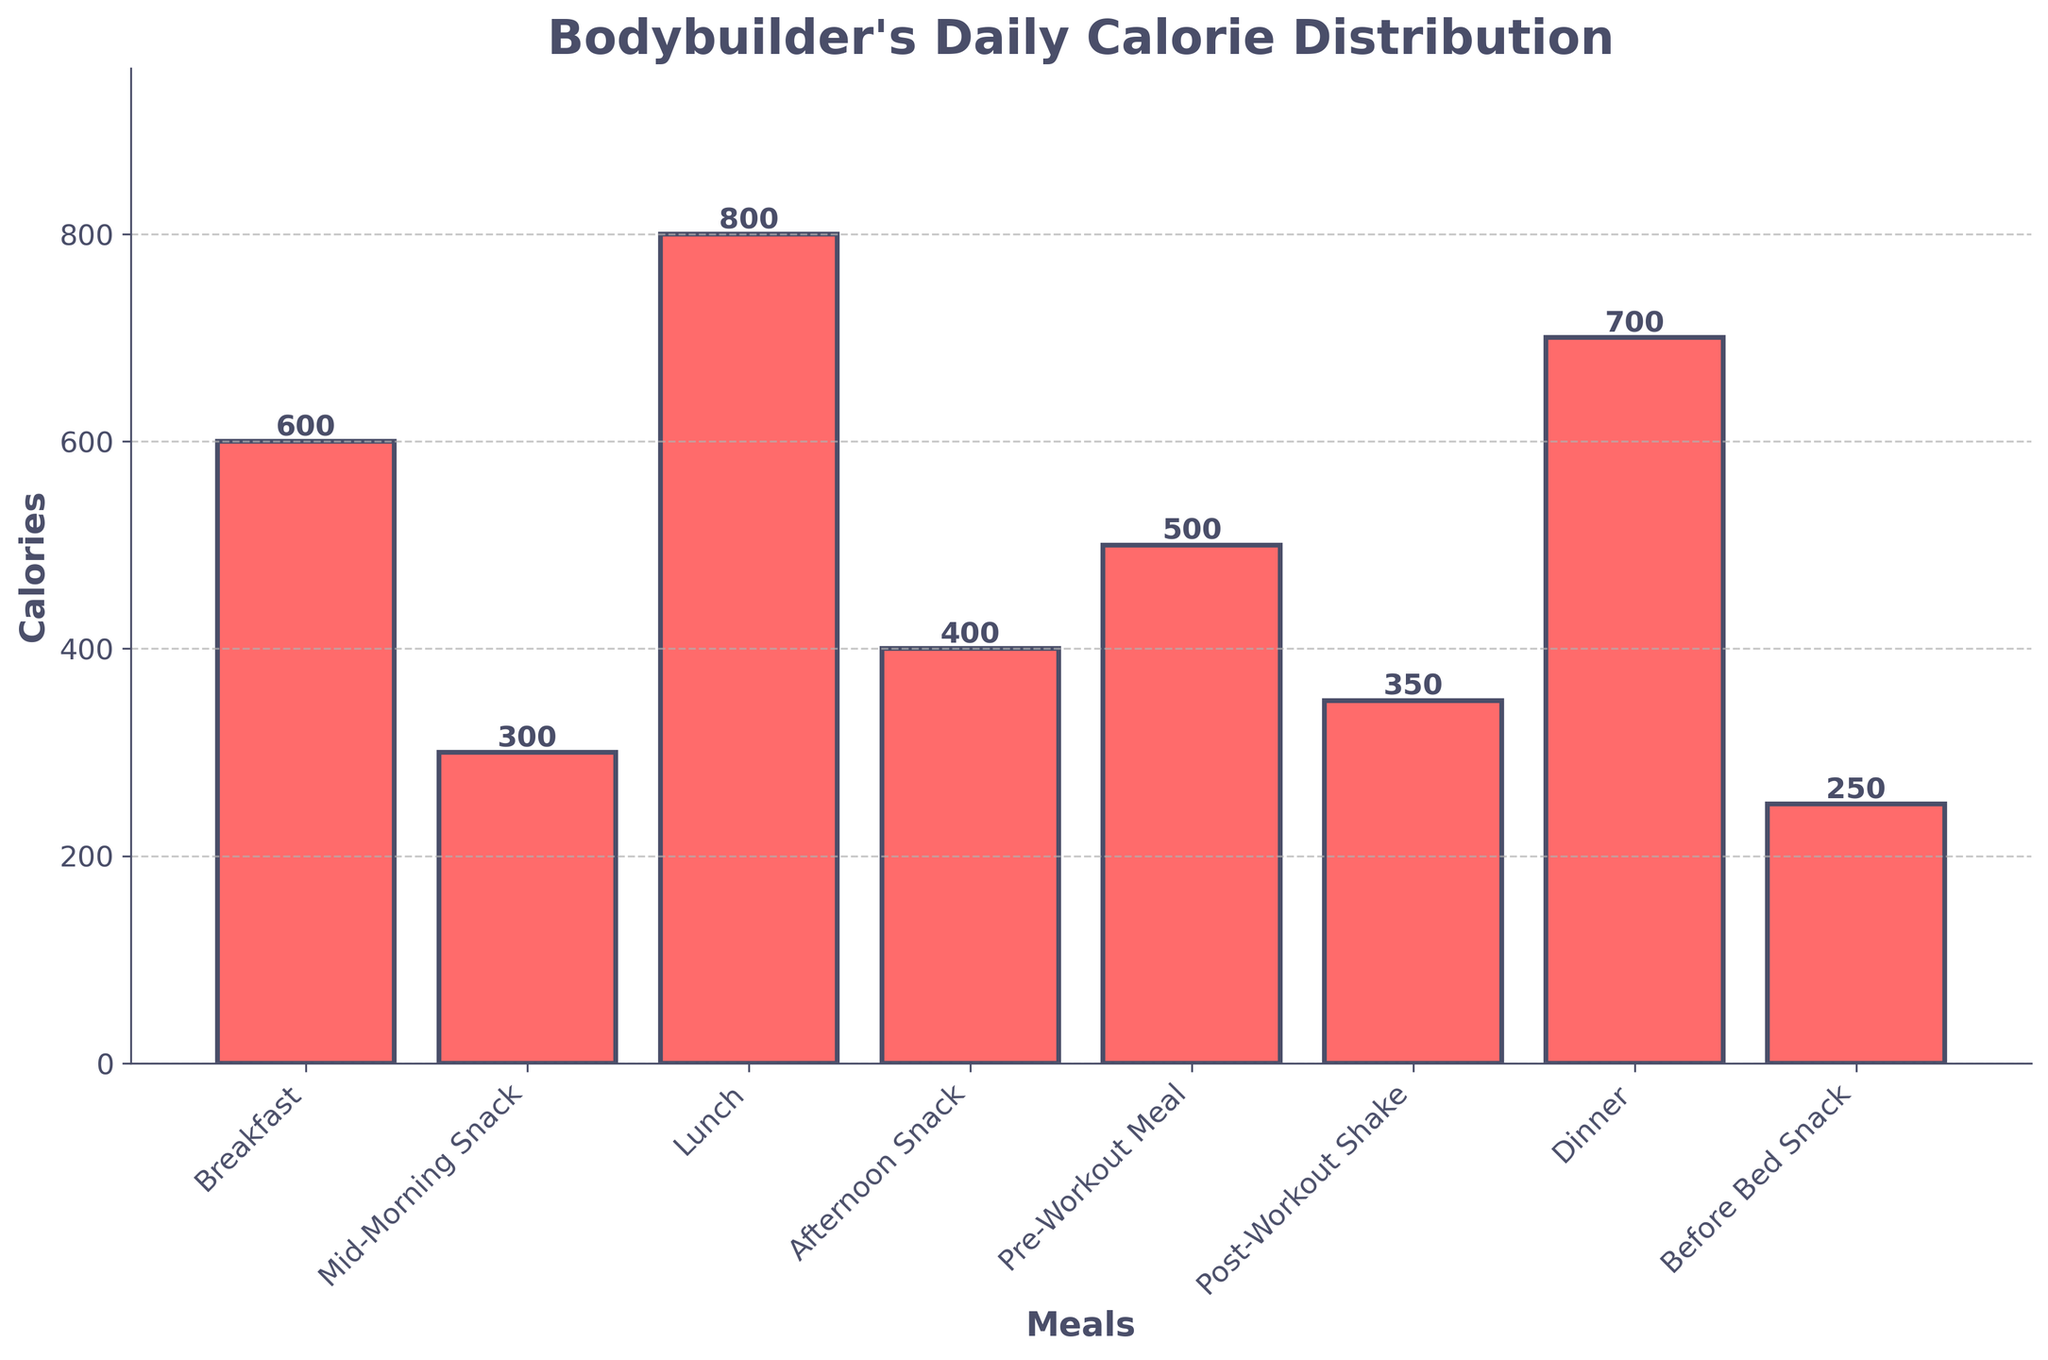What is the meal with the highest calorie count? By looking at the bars, the tallest one represents the meal with the highest calorie count, which is Lunch.
Answer: Lunch Which meal has fewer calories, Afternoon Snack or Dinner? By comparing the heights of the bars for Afternoon Snack and Dinner, Afternoon Snack (400 calories) is clearly shorter than Dinner (700 calories).
Answer: Afternoon Snack What is the total calorie intake from snacks (Mid-Morning Snack, Afternoon Snack, Before Bed Snack)? Add the calorie counts for Mid-Morning Snack (300), Afternoon Snack (400), and Before Bed Snack (250): 300 + 400 + 250 = 950 calories.
Answer: 950 Is Breakfast's calorie count greater than the total calorie count of both Pre-Workout Meal and Post-Workout Shake? Sum the calories of the Pre-Workout Meal and Post-Workout Shake first: 500 + 350 = 850. Then, compare this sum to Breakfast's calories: 600 < 850.
Answer: No How much less is the total calorie count of all snacks compared to the total calorie count of the main meals (Breakfast, Lunch, Dinner)? First, sum the calories for all snacks: Mid-Morning Snack (300) + Afternoon Snack (400) + Before Bed Snack (250) + Post-Workout Shake (350) = 1300. Then, sum the calories for the main meals: Breakfast (600) + Lunch (800) + Dinner (700) = 2100. Finally, subtract the total snack calories from the total main meal calories: 2100 - 1300 = 800.
Answer: 800 What is the average calorie count per meal? Calculate the average by summing up all the calorie values and then dividing by the number of meals: (600+300+800+400+500+350+700+250) / 8 = 3900 / 8 = 487.5 calories.
Answer: 487.5 Is the color of the bar representing Lunch different from the color representing Breakfast? By visually inspecting the chart, all bars are the same color shade of red.
Answer: No Which meals have a calorie count less than 400? By looking at the heights of the bars, the bars for Mid-Morning Snack (300), Post-Workout Shake (350), and Before Bed Snack (250) are all below 400 calories.
Answer: Mid-Morning Snack, Post-Workout Shake, Before Bed Snack What is the difference in calorie count between the highest and lowest calorie meals? Identify the highest (Lunch, 800 calories) and lowest (Before Bed Snack, 250 calories) calorie meals, then calculate the difference: 800 - 250 = 550 calories.
Answer: 550 How many meals have a calorie count greater than or equal to 500? Identify the bars at 500 calories or more: Breakfast (600), Lunch (800), Pre-Workout Meal (500), and Dinner (700). There are 4 meals meeting this criterion.
Answer: 4 